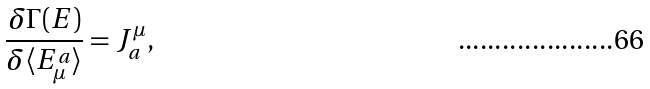<formula> <loc_0><loc_0><loc_500><loc_500>\frac { \delta \Gamma ( E ) } { \delta \langle E ^ { a } _ { \mu } \rangle } = J ^ { \mu } _ { a } ,</formula> 